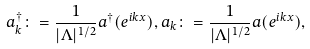<formula> <loc_0><loc_0><loc_500><loc_500>a _ { k } ^ { \dagger } \colon = \frac { 1 } { | \Lambda | ^ { 1 / 2 } } a ^ { \dagger } ( e ^ { i k x } ) , a _ { k } \colon = \frac { 1 } { | \Lambda | ^ { 1 / 2 } } a ( e ^ { i k x } ) ,</formula> 